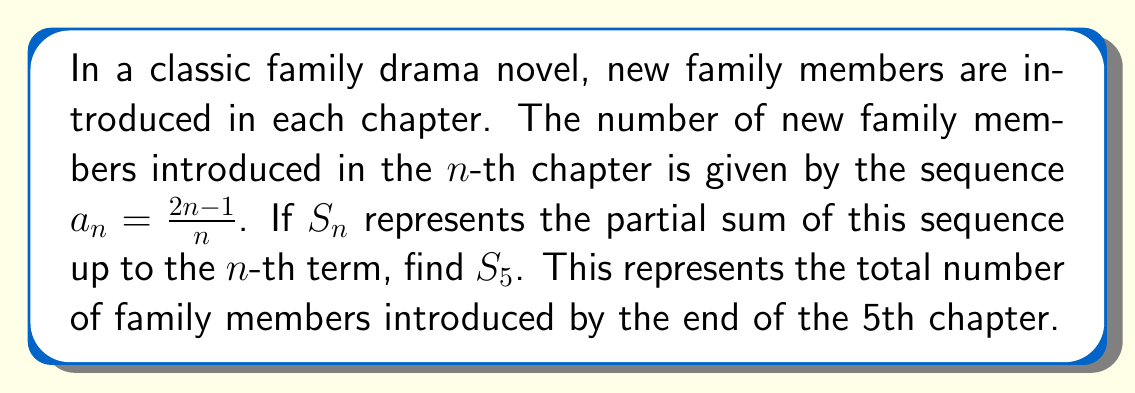Show me your answer to this math problem. To solve this problem, we need to follow these steps:

1) First, let's write out the first 5 terms of the sequence:

   $a_1 = \frac{2(1)-1}{1} = 1$
   $a_2 = \frac{2(2)-1}{2} = \frac{3}{2}$
   $a_3 = \frac{2(3)-1}{3} = \frac{5}{3}$
   $a_4 = \frac{2(4)-1}{4} = \frac{7}{4}$
   $a_5 = \frac{2(5)-1}{5} = \frac{9}{5}$

2) The partial sum $S_5$ is the sum of these 5 terms:

   $S_5 = a_1 + a_2 + a_3 + a_4 + a_5$

3) Substituting the values:

   $S_5 = 1 + \frac{3}{2} + \frac{5}{3} + \frac{7}{4} + \frac{9}{5}$

4) To add these fractions, we need a common denominator. The least common multiple of 1, 2, 3, 4, and 5 is 60. Let's convert each fraction:

   $S_5 = \frac{60}{60} + \frac{90}{60} + \frac{100}{60} + \frac{105}{60} + \frac{108}{60}$

5) Now we can add the numerators:

   $S_5 = \frac{60 + 90 + 100 + 105 + 108}{60} = \frac{463}{60}$

6) This fraction can be reduced by dividing both numerator and denominator by their greatest common divisor, which is 1.

Therefore, the final answer is $\frac{463}{60}$.
Answer: $S_5 = \frac{463}{60}$ 